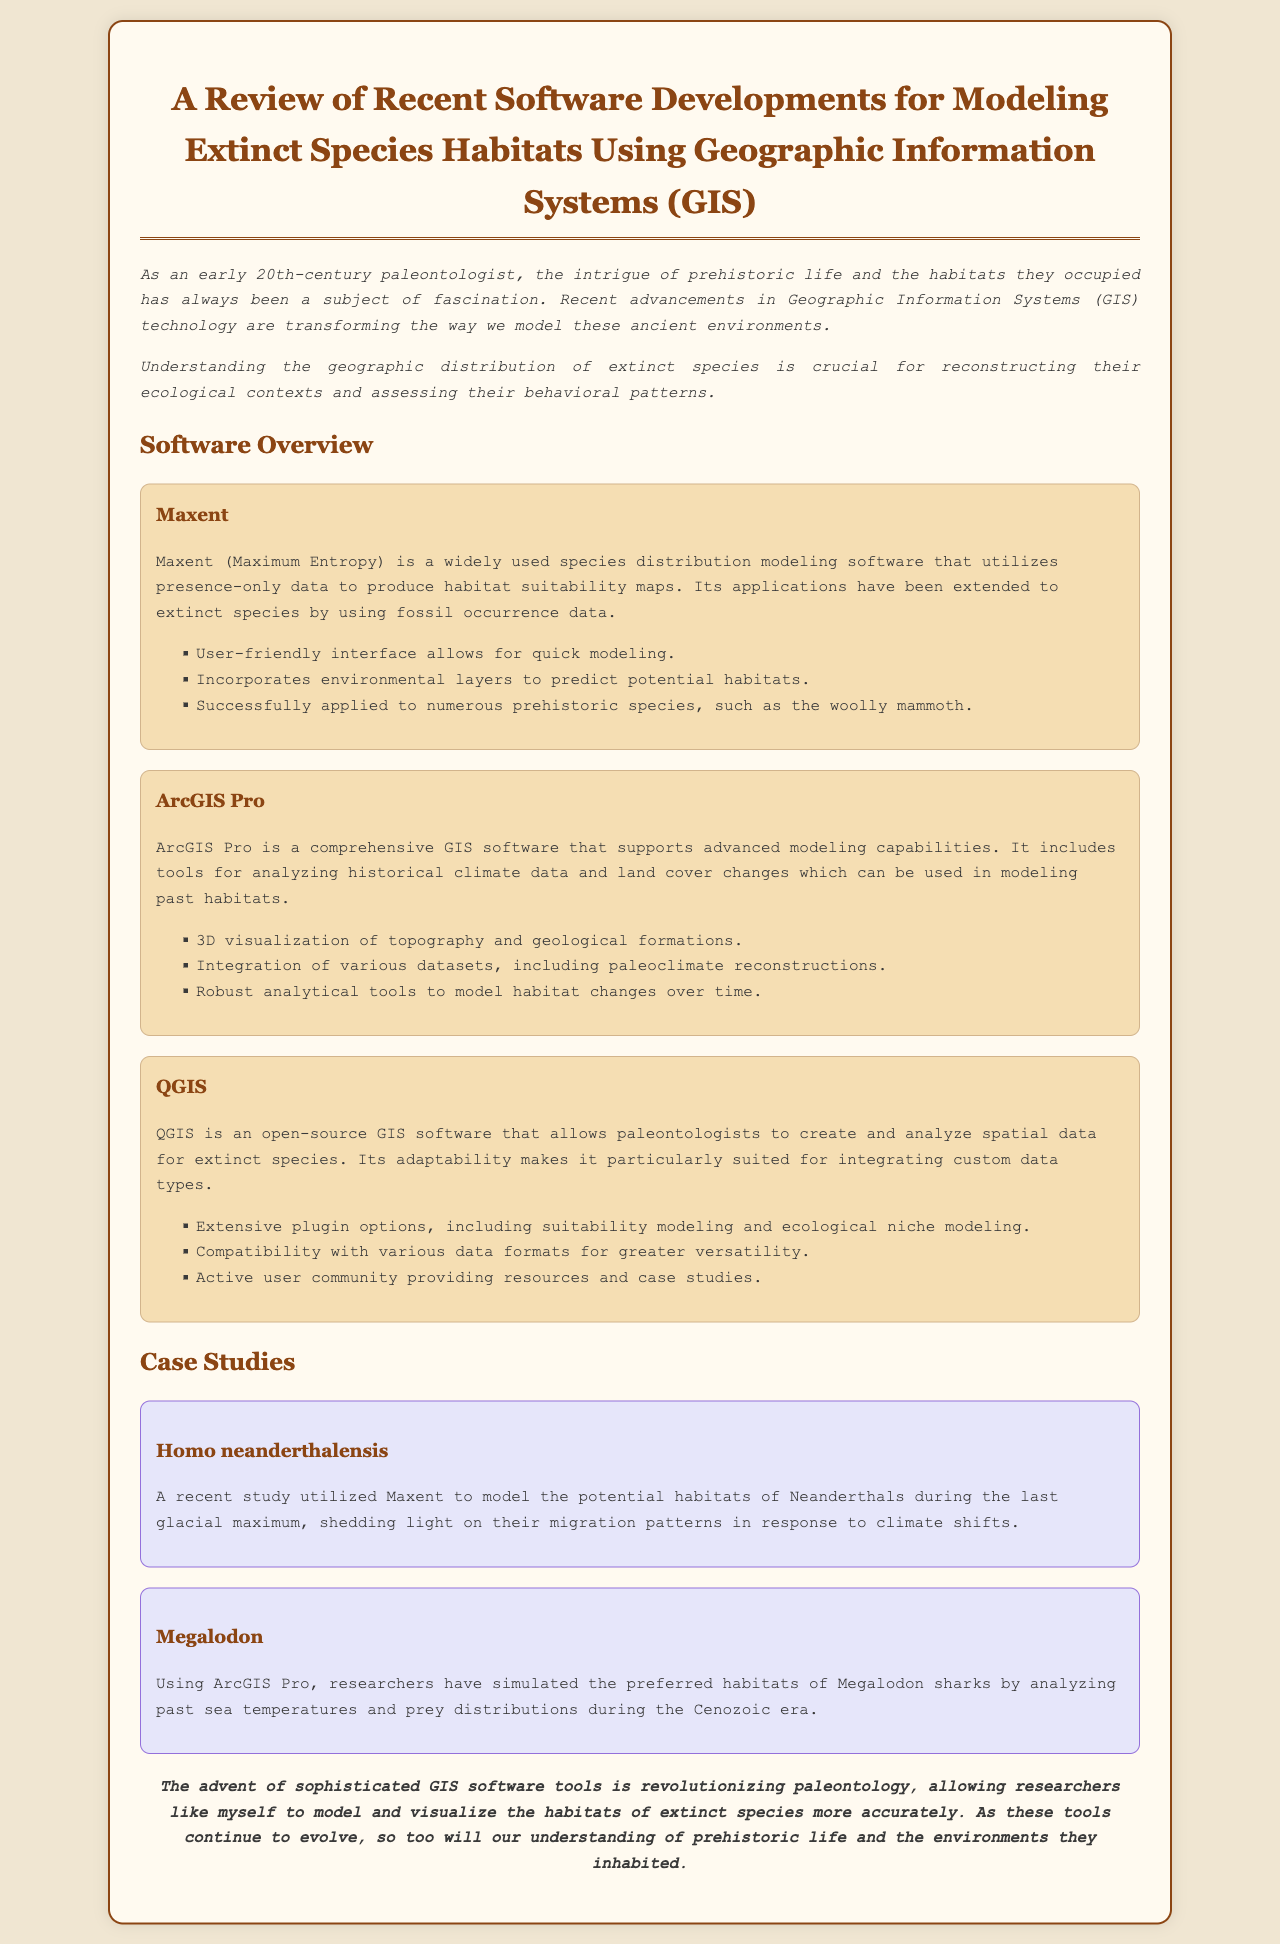What is the title of the document? The title appears at the top of the document and summarizes the main topic covered.
Answer: A Review of Recent Software Developments for Modeling Extinct Species Habitats Using Geographic Information Systems (GIS) Which software is known for using presence-only data? The document explicitly states that Maxent utilizes presence-only data.
Answer: Maxent What extinct species was studied using Maxent? The specific historical subject of the study is mentioned in the case studies section related to Maxent.
Answer: Homo neanderthalensis What GIS software provides 3D visualization capabilities? The document highlights this feature in the overview of ArcGIS Pro.
Answer: ArcGIS Pro What technology is transforming the modeling of ancient environments? The document discusses how a specific type of technology is evolving and impacting the field.
Answer: Geographic Information Systems (GIS) Which extinct species was simulated using ArcGIS Pro? This information is clearly stated in the case study section of the document.
Answer: Megalodon What aspect of habitats does QGIS particularly allow for? The document describes a significant feature of QGIS related to spatial data.
Answer: Create and analyze spatial data How did researchers analyze past sea temperatures for Megalodon? This refers to the methods employed in the research mentioned in the case study.
Answer: By analyzing past sea temperatures and prey distributions 